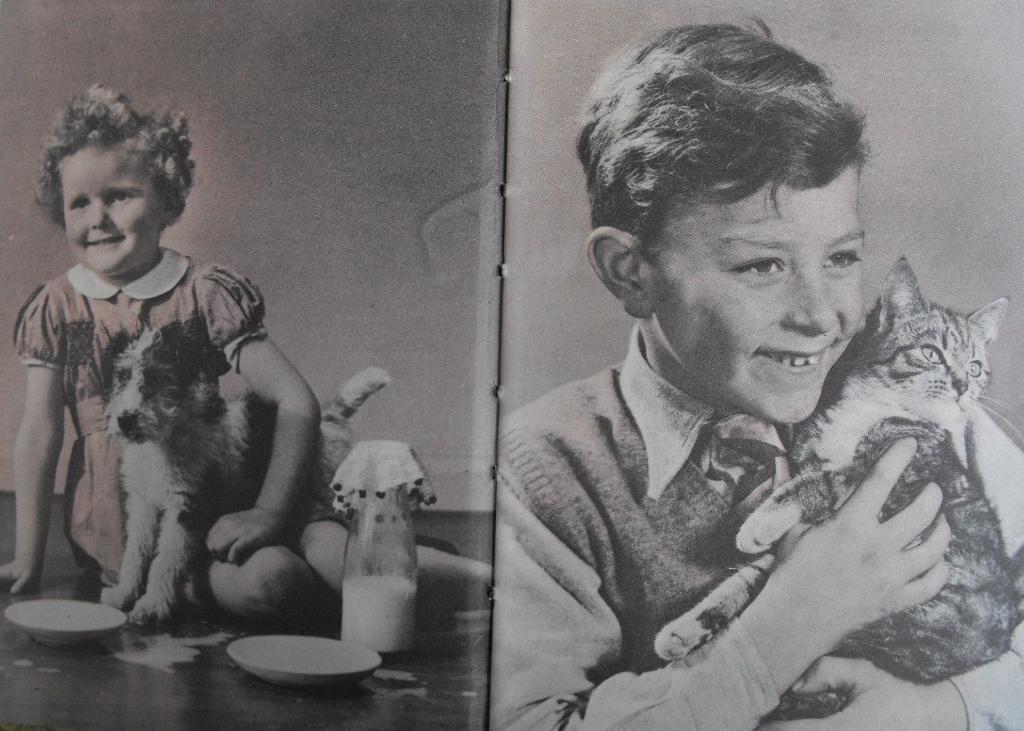Please provide a concise description of this image. Bottom right side of the image a boy is holding a cat and smiling. Bottom left side of the image a girl is sitting on the floor and holding a dog, Beside her there is a bottle and there are two saucers. 